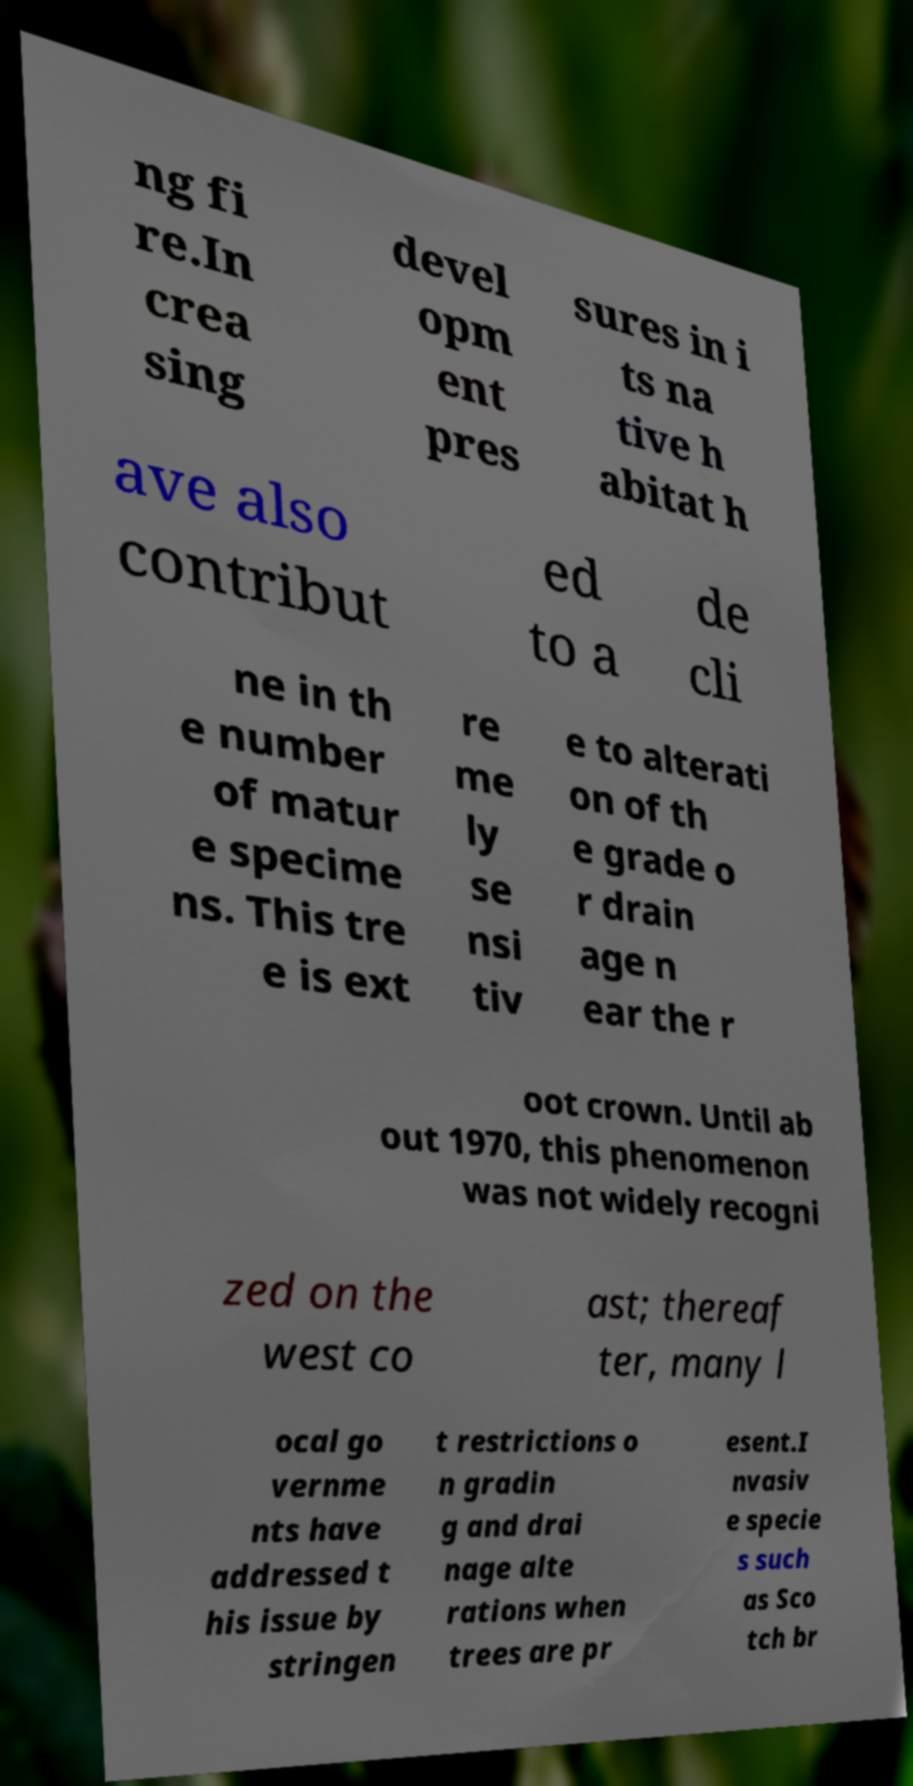What messages or text are displayed in this image? I need them in a readable, typed format. ng fi re.In crea sing devel opm ent pres sures in i ts na tive h abitat h ave also contribut ed to a de cli ne in th e number of matur e specime ns. This tre e is ext re me ly se nsi tiv e to alterati on of th e grade o r drain age n ear the r oot crown. Until ab out 1970, this phenomenon was not widely recogni zed on the west co ast; thereaf ter, many l ocal go vernme nts have addressed t his issue by stringen t restrictions o n gradin g and drai nage alte rations when trees are pr esent.I nvasiv e specie s such as Sco tch br 